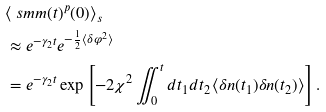Convert formula to latex. <formula><loc_0><loc_0><loc_500><loc_500>& \langle \ s m m ( t ) ^ { p } ( 0 ) \rangle _ { s } \\ & \approx e ^ { - \gamma _ { 2 } t } e ^ { - \frac { 1 } { 2 } \langle \delta \varphi ^ { 2 } \rangle } \\ & = e ^ { - \gamma _ { 2 } t } \exp \left [ - 2 \chi ^ { 2 } \iint _ { 0 } ^ { t } d t _ { 1 } d t _ { 2 } \langle \delta n ( t _ { 1 } ) \delta n ( t _ { 2 } ) \rangle \right ] .</formula> 